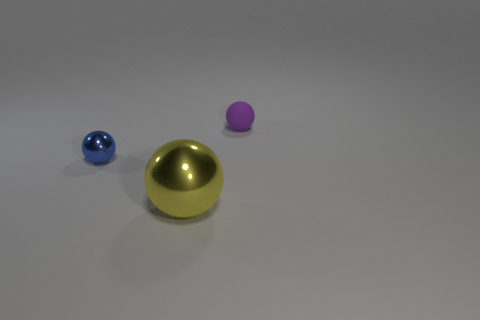Are there an equal number of matte things that are in front of the yellow thing and small balls that are behind the small rubber thing?
Your answer should be compact. Yes. Is there another purple ball that has the same material as the small purple sphere?
Give a very brief answer. No. Are the purple object and the large ball made of the same material?
Provide a short and direct response. No. How many brown things are either metallic balls or cylinders?
Keep it short and to the point. 0. Are there more tiny objects to the right of the large metallic ball than tiny purple balls?
Provide a succinct answer. No. Is there a big metal sphere that has the same color as the large object?
Keep it short and to the point. No. What is the size of the blue sphere?
Make the answer very short. Small. Is the rubber thing the same color as the small metal sphere?
Your answer should be compact. No. How many objects are either large green matte blocks or metallic objects that are in front of the tiny shiny ball?
Offer a terse response. 1. There is a tiny sphere that is on the left side of the tiny ball right of the blue ball; what number of large yellow metallic things are in front of it?
Provide a succinct answer. 1. 